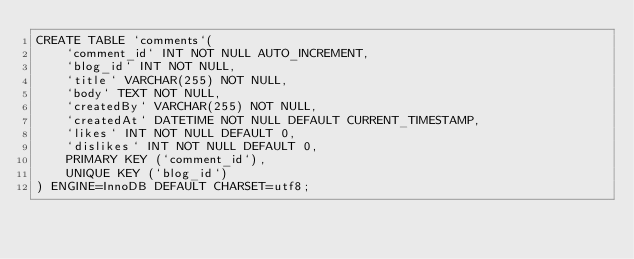Convert code to text. <code><loc_0><loc_0><loc_500><loc_500><_SQL_>CREATE TABLE `comments`(
    `comment_id` INT NOT NULL AUTO_INCREMENT,
    `blog_id` INT NOT NULL,
    `title` VARCHAR(255) NOT NULL,
    `body` TEXT NOT NULL,
    `createdBy` VARCHAR(255) NOT NULL,
    `createdAt` DATETIME NOT NULL DEFAULT CURRENT_TIMESTAMP,
    `likes` INT NOT NULL DEFAULT 0,
    `dislikes` INT NOT NULL DEFAULT 0,
    PRIMARY KEY (`comment_id`),
    UNIQUE KEY (`blog_id`)
) ENGINE=InnoDB DEFAULT CHARSET=utf8;</code> 